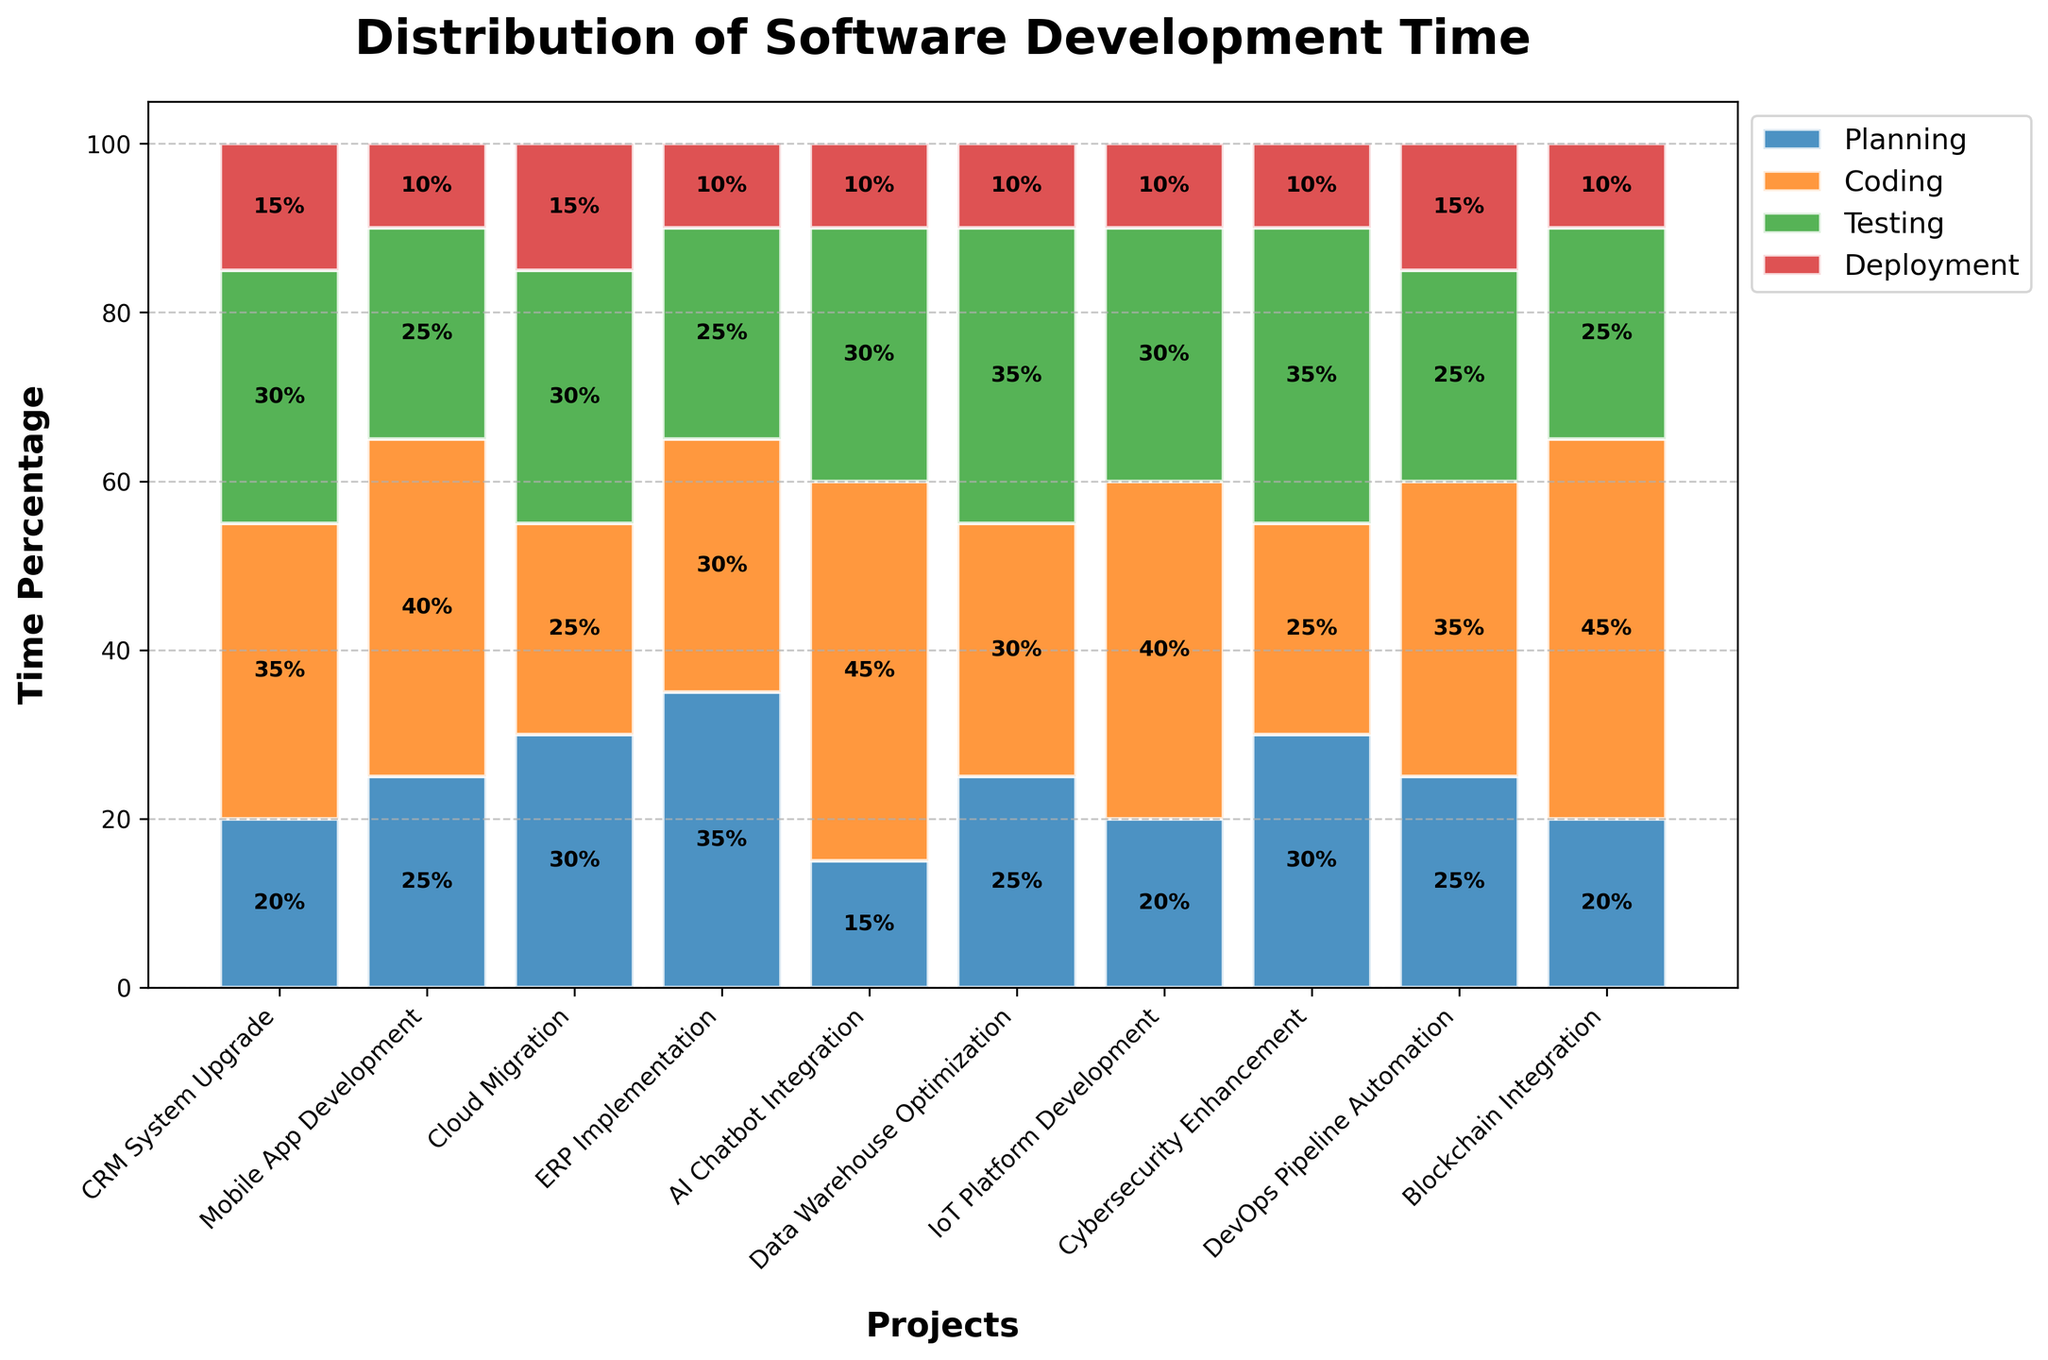What's the project with the highest percentage of time spent on coding? The bar corresponding to coding is the tallest for the "AI Chatbot Integration" project with 45%.
Answer: AI Chatbot Integration Which phases have the highest and lowest percentage of time for the "Data Warehouse Optimization" project? For "Data Warehouse Optimization," the highest is Testing at 35%, and the lowest is Deployment at 10%.
Answer: Highest: Testing, Lowest: Deployment How much time, in total percentage, was spent on Testing for "CRM System Upgrade" and "Cybersecurity Enhancement"? Summing up the Testing percentages of the two projects: 30% (CRM System Upgrade) + 35% (Cybersecurity Enhancement) = 65%.
Answer: 65% What is the difference in planning time between "ERP Implementation" and "Mobile App Development"? The Planning time for "ERP Implementation" is 35% and for "Mobile App Development" is 25%. The difference is 35% - 25% = 10%.
Answer: 10% Among the listed phases, which one is consistently the shortest phase across the most projects? Deployment consistently has the shortest bars across the majority of projects, usually around 10-15%.
Answer: Deployment Is there any project where the coding phase takes up exactly 40% of the time? By examining the height of the bars corresponding to Coding, projects with exactly 40% are "Mobile App Development" and "IoT Platform Development."
Answer: Yes (Mobile App Development, IoT Platform Development) Calculate the average time spent on Deployment across all projects. Total Deployment percentages: 15 + 10 + 15 + 10 + 10 + 10 + 10 + 10 + 15 + 10 = 115%. Number of projects = 10. Average = 115% / 10 = 11.5%.
Answer: 11.5% Which project dedicated equal time to Planning and Deployment, and what is the time percentage? By observing the bars, the "DevOps Pipeline Automation" project has both Planning and Deployment phases at 25%.
Answer: DevOps Pipeline Automation, 25% Compare the Coding times for "CRM System Upgrade" and "Blockchain Integration"; which one is higher and by how much? "CRM System Upgrade" has 35% for Coding, whereas "Blockchain Integration" has 45%. 45% - 35% = 10%.
Answer: Blockchain Integration by 10% 